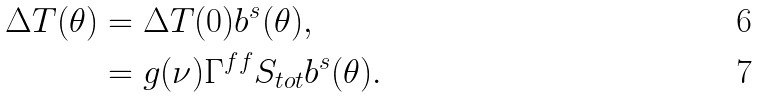<formula> <loc_0><loc_0><loc_500><loc_500>\Delta T ( \theta ) & = \Delta T ( 0 ) b ^ { s } ( \theta ) , \\ & = g ( \nu ) \Gamma ^ { f f } S _ { t o t } b ^ { s } ( \theta ) .</formula> 